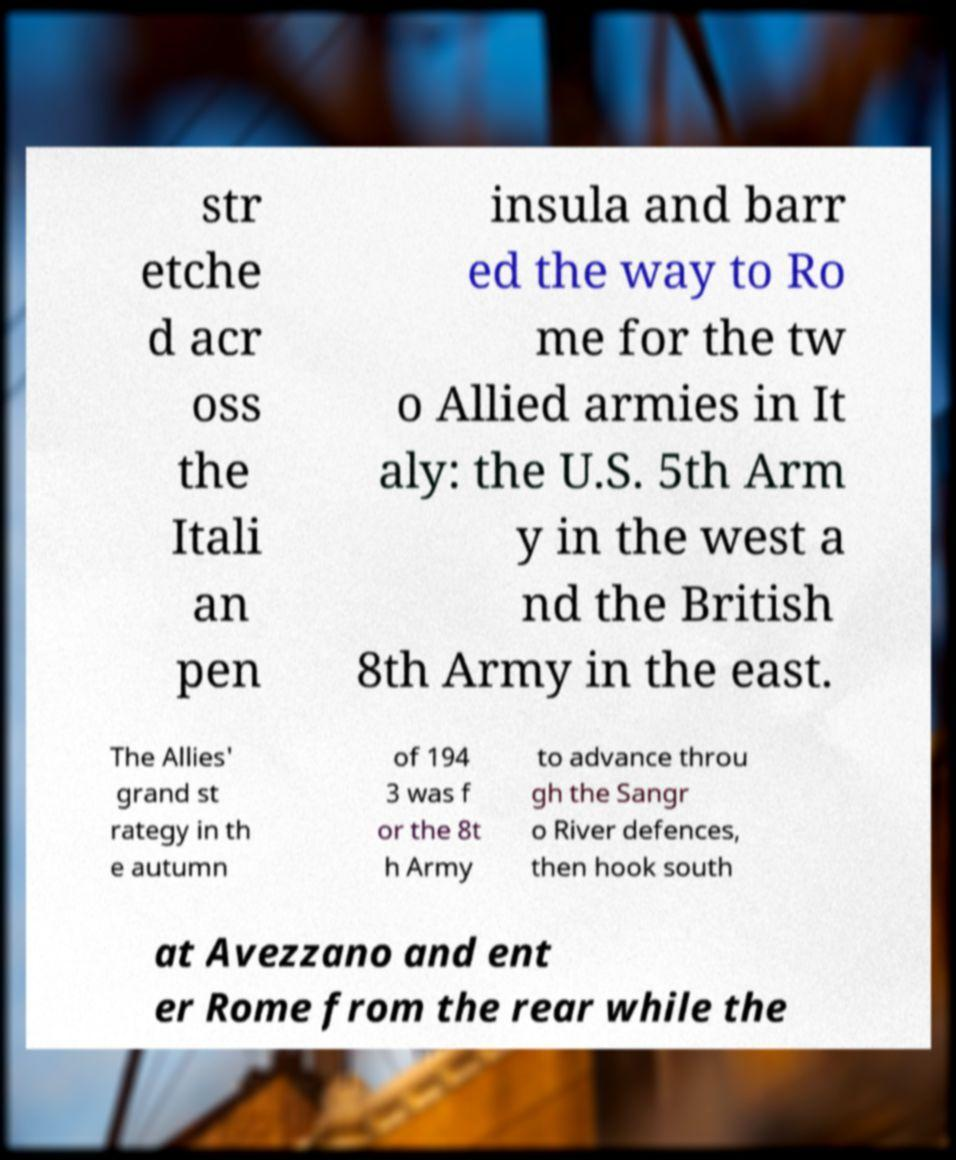Please identify and transcribe the text found in this image. str etche d acr oss the Itali an pen insula and barr ed the way to Ro me for the tw o Allied armies in It aly: the U.S. 5th Arm y in the west a nd the British 8th Army in the east. The Allies' grand st rategy in th e autumn of 194 3 was f or the 8t h Army to advance throu gh the Sangr o River defences, then hook south at Avezzano and ent er Rome from the rear while the 